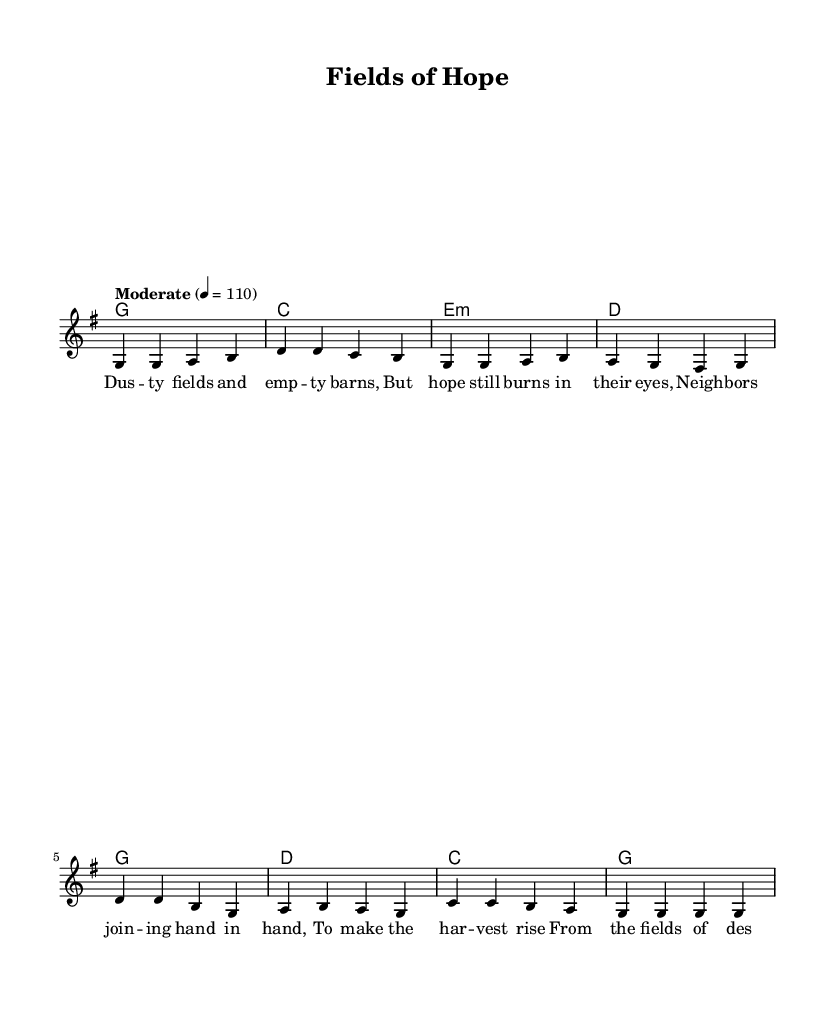What is the key signature of this music? The key signature is G major, indicated by the presence of one sharp (F#).
Answer: G major What is the time signature? The time signature is 4/4, which means there are four beats in each measure.
Answer: 4/4 What is the tempo marking for this piece? The tempo marking is "Moderate," with a metronome marking of quarter note equals 110 beats per minute.
Answer: Moderate How many measures are there in the verse? There are four measures in the verse, as indicated by the sequences of notes under the verse lyrics.
Answer: Four What is the main theme of the lyrics? The main theme of the lyrics is resilience in the face of despair, focusing on community support during hardships like food shortages.
Answer: Resilience In the chorus, which two keys are played? The keys played in the chorus are D major and G major, as seen in the chord progression.
Answer: D major and G major What is the purpose of the song in relation to food shortages? The purpose of the song is to inspire hope and unity in resilient communities overcoming food shortages, highlighted by the lyrics' message.
Answer: Inspire hope 